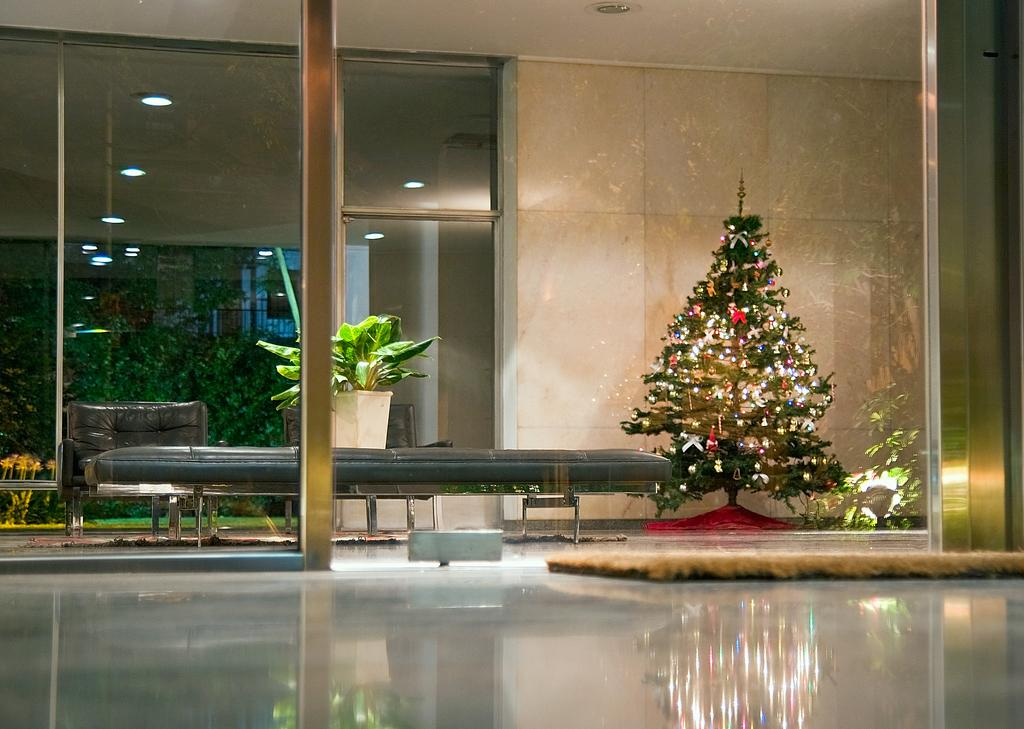What is in the foreground of the image? There is a floor and a glass in the foreground of the image. What is placed on the floor? There is a mat on the floor. What can be seen in the background of the image? There is a bench, a Christmas tree, a plant, sofas, and greenery in the background of the image. What is the ceiling like in the image? There is a ceiling visible in the image. What type of music is being played on the throne in the image? There is no throne present in the image, and therefore no music being played on it. Who brought the pie to the gathering in the image? There is no pie present in the image, so it cannot be determined who brought it. 